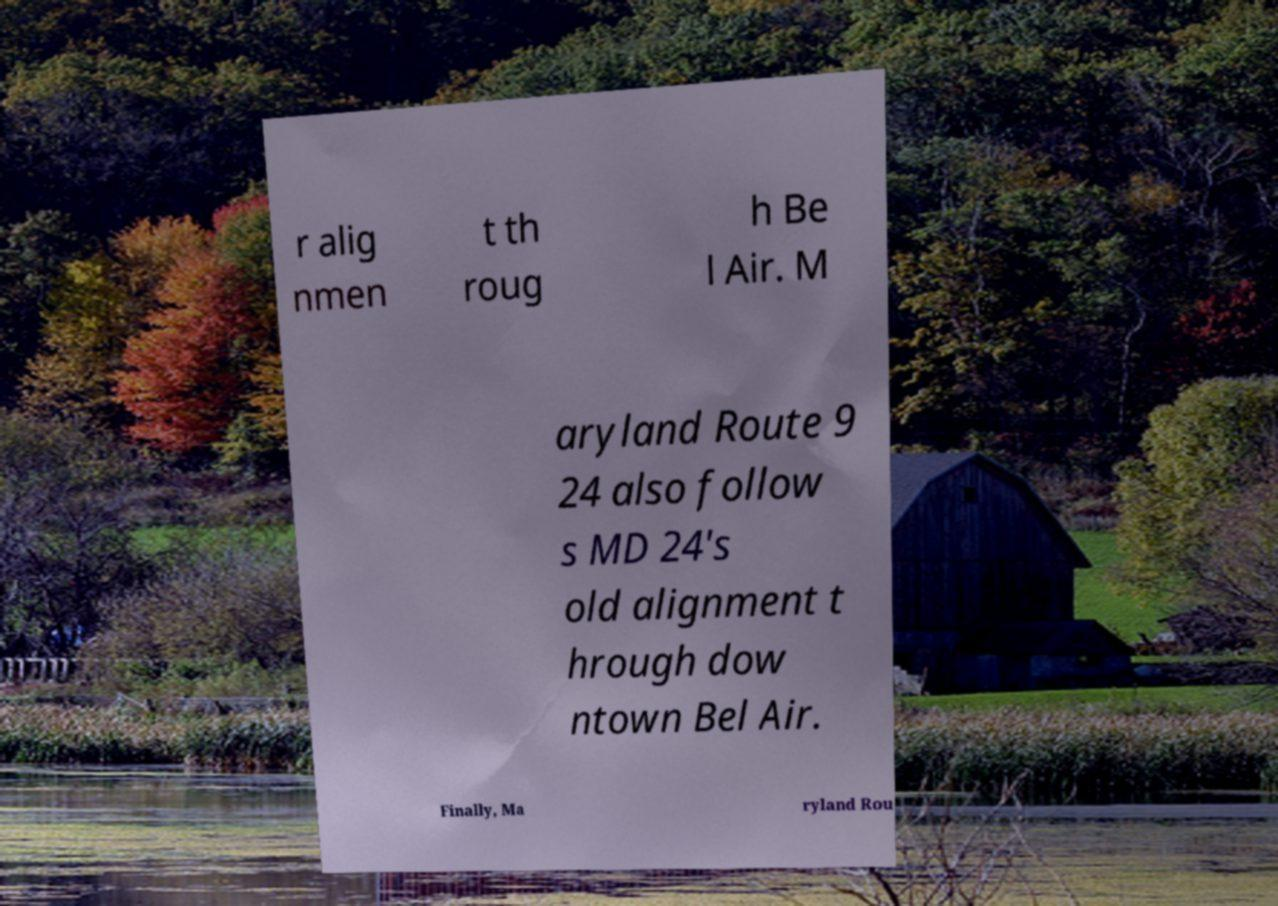What messages or text are displayed in this image? I need them in a readable, typed format. r alig nmen t th roug h Be l Air. M aryland Route 9 24 also follow s MD 24's old alignment t hrough dow ntown Bel Air. Finally, Ma ryland Rou 